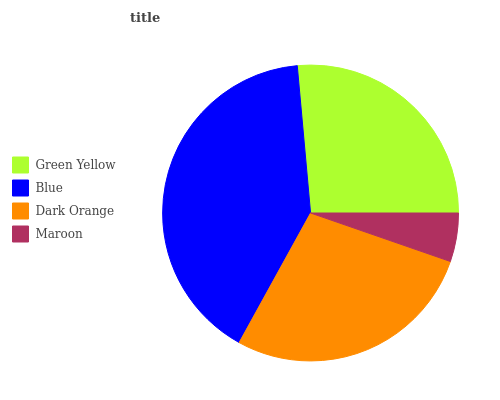Is Maroon the minimum?
Answer yes or no. Yes. Is Blue the maximum?
Answer yes or no. Yes. Is Dark Orange the minimum?
Answer yes or no. No. Is Dark Orange the maximum?
Answer yes or no. No. Is Blue greater than Dark Orange?
Answer yes or no. Yes. Is Dark Orange less than Blue?
Answer yes or no. Yes. Is Dark Orange greater than Blue?
Answer yes or no. No. Is Blue less than Dark Orange?
Answer yes or no. No. Is Dark Orange the high median?
Answer yes or no. Yes. Is Green Yellow the low median?
Answer yes or no. Yes. Is Maroon the high median?
Answer yes or no. No. Is Blue the low median?
Answer yes or no. No. 